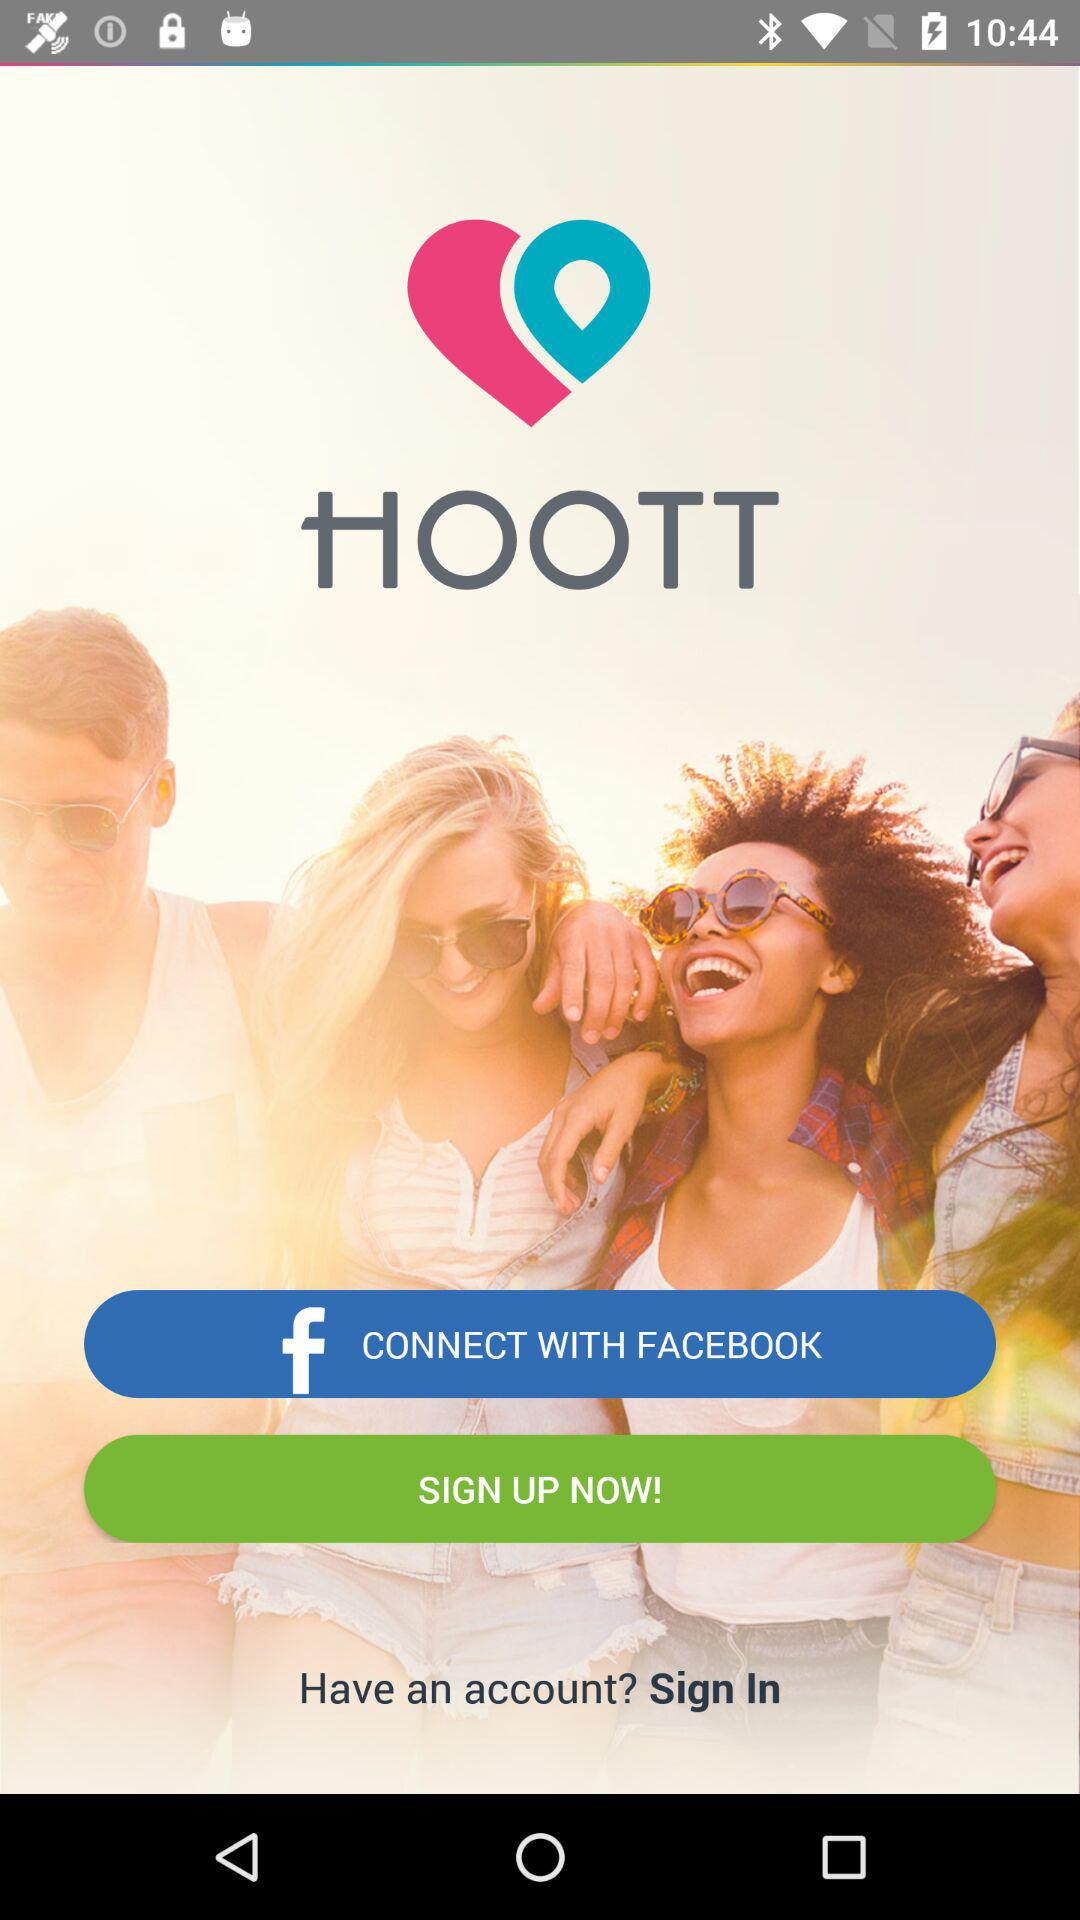What is the name of the application? The name of the application is "HOOTT". 